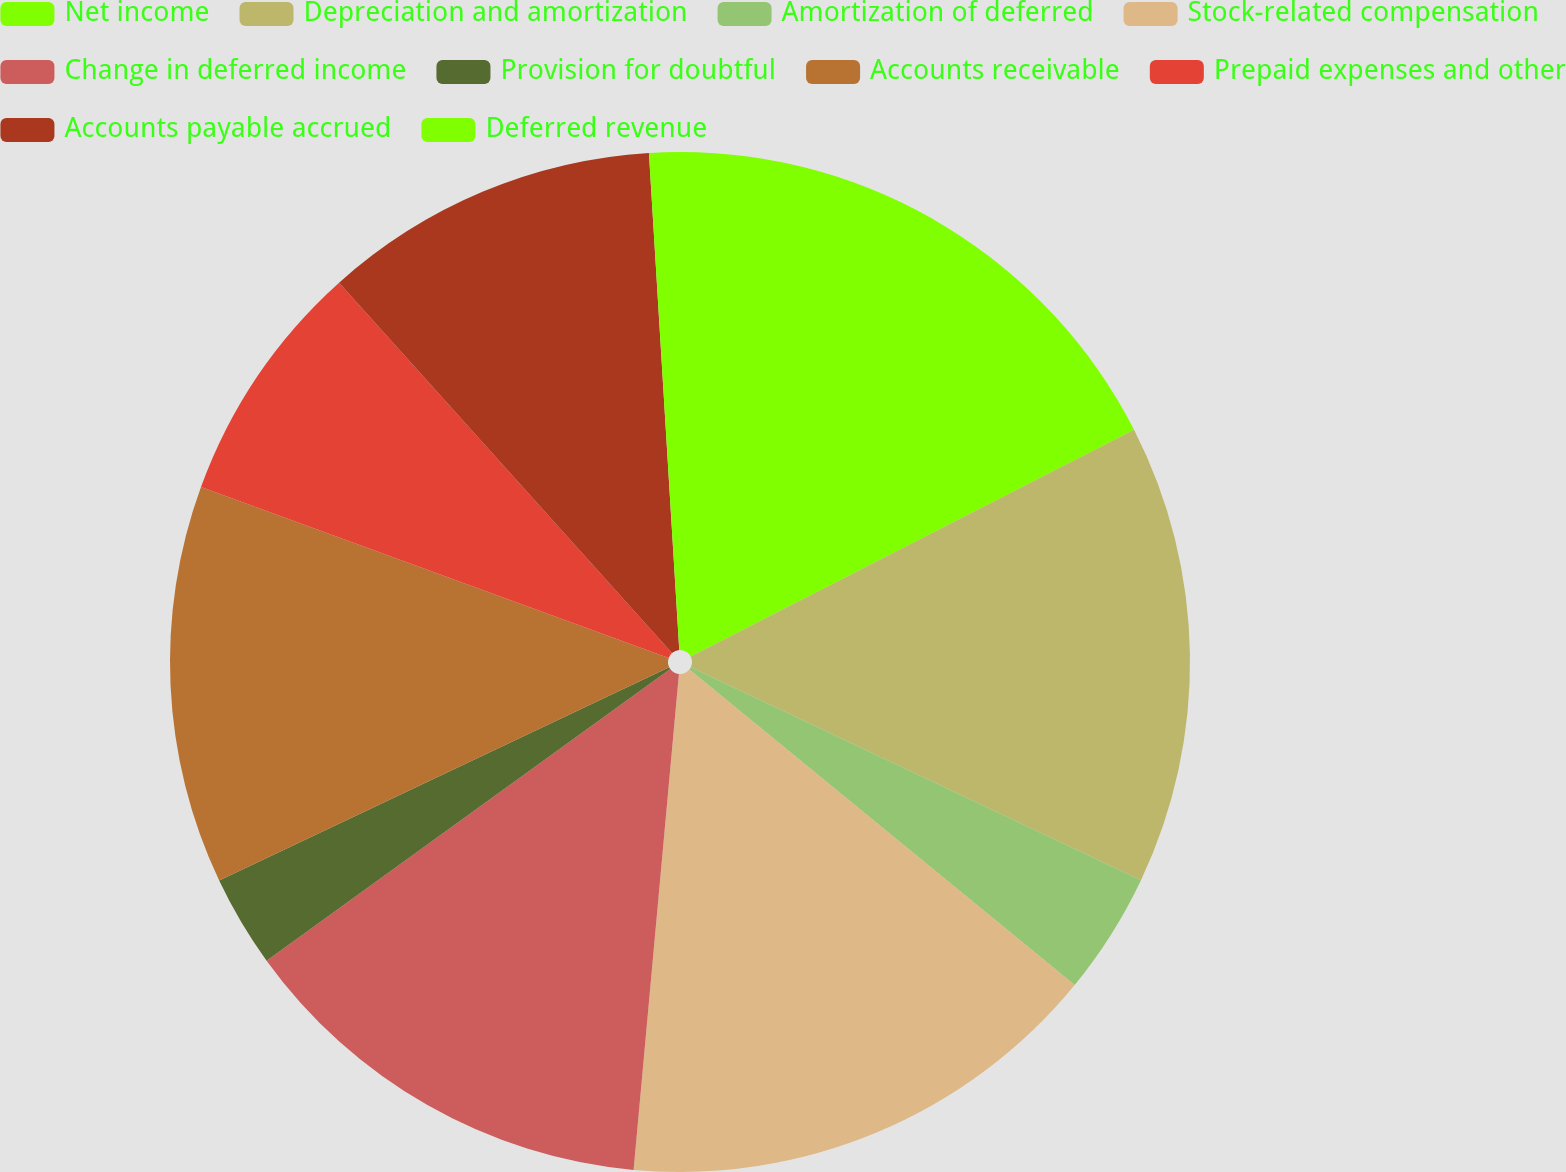<chart> <loc_0><loc_0><loc_500><loc_500><pie_chart><fcel>Net income<fcel>Depreciation and amortization<fcel>Amortization of deferred<fcel>Stock-related compensation<fcel>Change in deferred income<fcel>Provision for doubtful<fcel>Accounts receivable<fcel>Prepaid expenses and other<fcel>Accounts payable accrued<fcel>Deferred revenue<nl><fcel>17.47%<fcel>14.56%<fcel>3.88%<fcel>15.53%<fcel>13.59%<fcel>2.91%<fcel>12.62%<fcel>7.77%<fcel>10.68%<fcel>0.97%<nl></chart> 